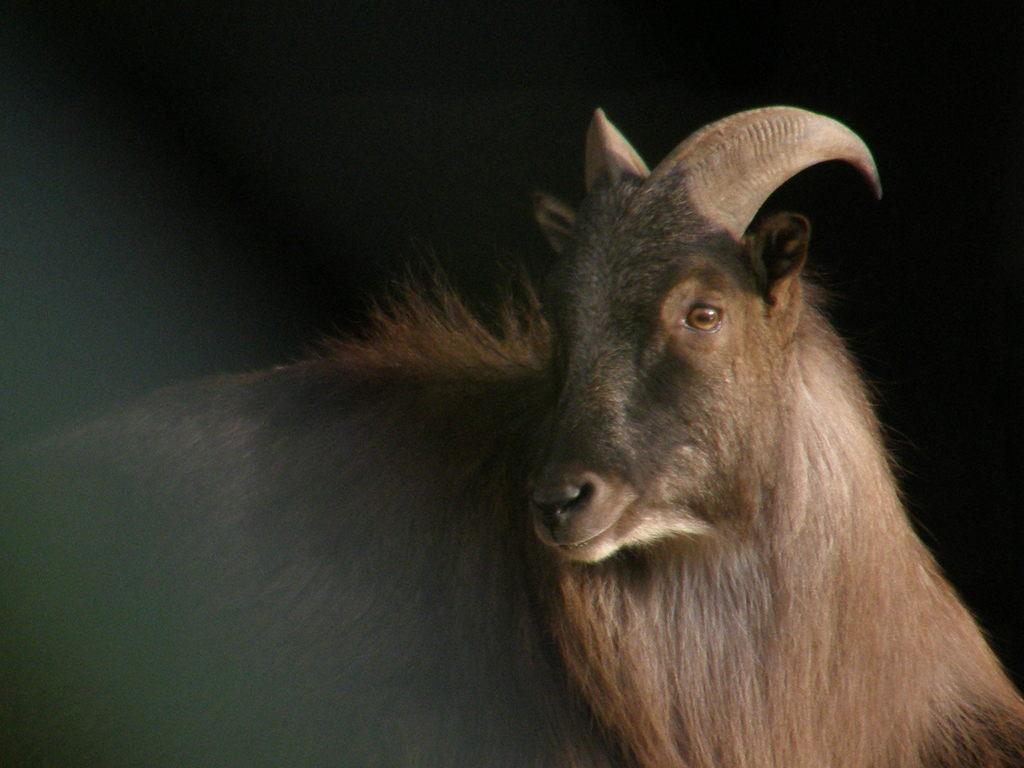In one or two sentences, can you explain what this image depicts? In this image there is an animal. The background is dark. 